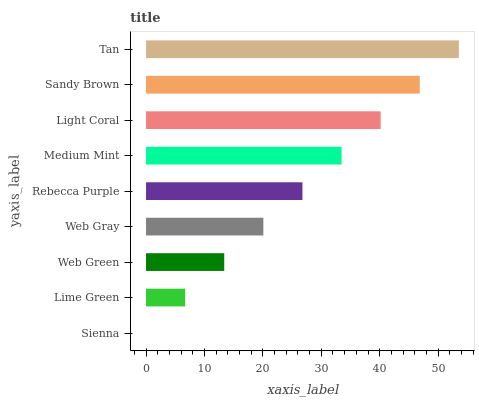Is Sienna the minimum?
Answer yes or no. Yes. Is Tan the maximum?
Answer yes or no. Yes. Is Lime Green the minimum?
Answer yes or no. No. Is Lime Green the maximum?
Answer yes or no. No. Is Lime Green greater than Sienna?
Answer yes or no. Yes. Is Sienna less than Lime Green?
Answer yes or no. Yes. Is Sienna greater than Lime Green?
Answer yes or no. No. Is Lime Green less than Sienna?
Answer yes or no. No. Is Rebecca Purple the high median?
Answer yes or no. Yes. Is Rebecca Purple the low median?
Answer yes or no. Yes. Is Tan the high median?
Answer yes or no. No. Is Lime Green the low median?
Answer yes or no. No. 